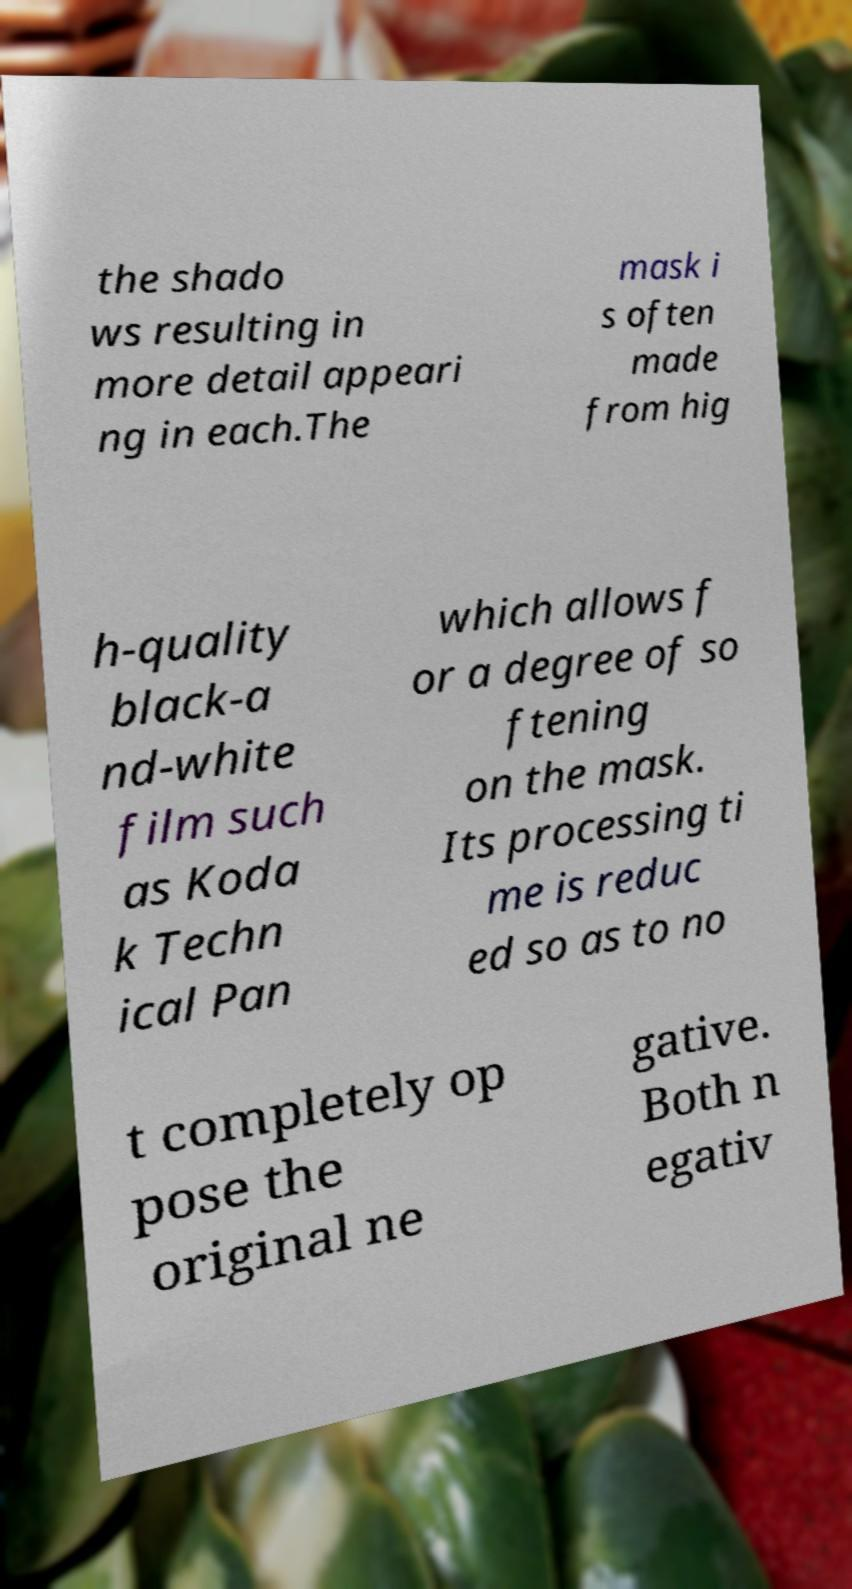Could you extract and type out the text from this image? the shado ws resulting in more detail appeari ng in each.The mask i s often made from hig h-quality black-a nd-white film such as Koda k Techn ical Pan which allows f or a degree of so ftening on the mask. Its processing ti me is reduc ed so as to no t completely op pose the original ne gative. Both n egativ 